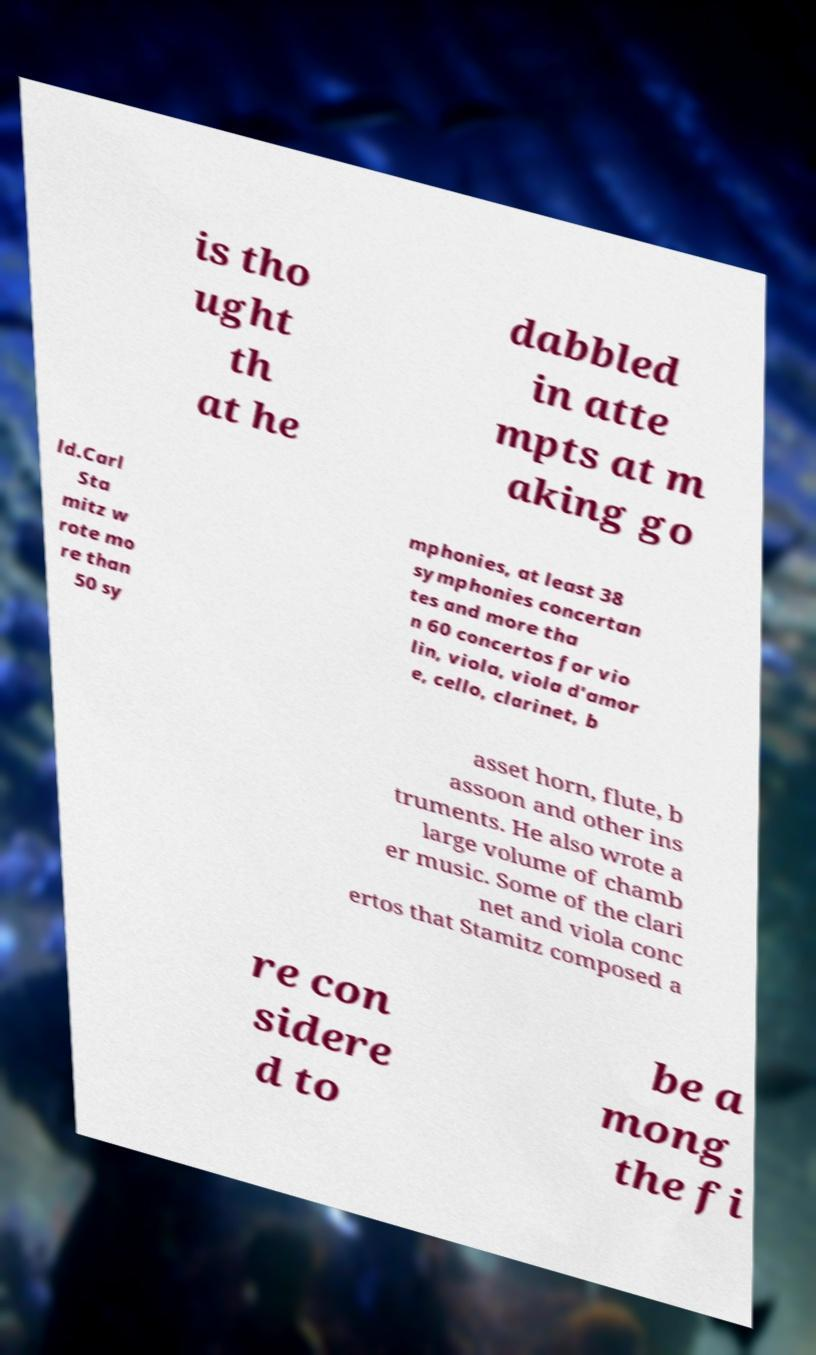For documentation purposes, I need the text within this image transcribed. Could you provide that? is tho ught th at he dabbled in atte mpts at m aking go ld.Carl Sta mitz w rote mo re than 50 sy mphonies, at least 38 symphonies concertan tes and more tha n 60 concertos for vio lin, viola, viola d'amor e, cello, clarinet, b asset horn, flute, b assoon and other ins truments. He also wrote a large volume of chamb er music. Some of the clari net and viola conc ertos that Stamitz composed a re con sidere d to be a mong the fi 